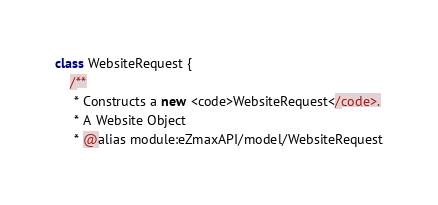<code> <loc_0><loc_0><loc_500><loc_500><_JavaScript_>class WebsiteRequest {
    /**
     * Constructs a new <code>WebsiteRequest</code>.
     * A Website Object
     * @alias module:eZmaxAPI/model/WebsiteRequest</code> 